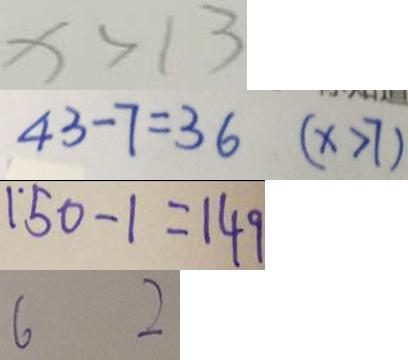<formula> <loc_0><loc_0><loc_500><loc_500>x > 1 3 
 4 3 - 7 = 3 6 ( x > 7 ) 
 1 5 0 - 1 = 1 4 9 
 6 2</formula> 